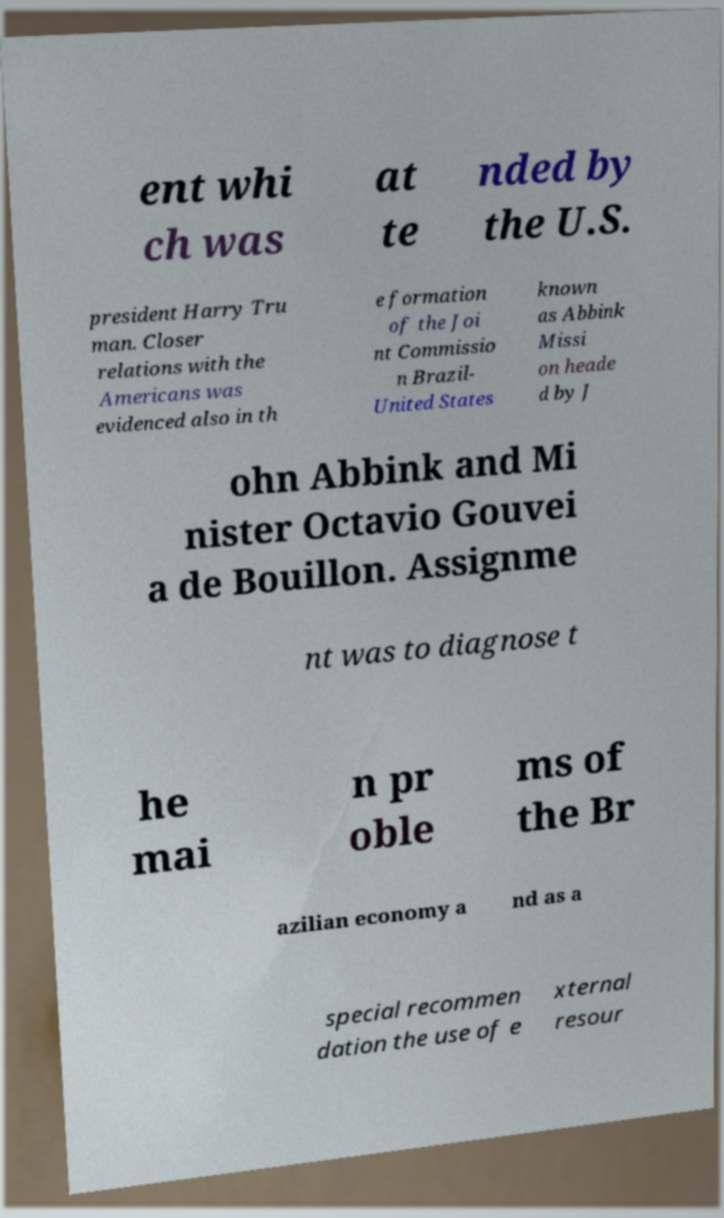There's text embedded in this image that I need extracted. Can you transcribe it verbatim? ent whi ch was at te nded by the U.S. president Harry Tru man. Closer relations with the Americans was evidenced also in th e formation of the Joi nt Commissio n Brazil- United States known as Abbink Missi on heade d by J ohn Abbink and Mi nister Octavio Gouvei a de Bouillon. Assignme nt was to diagnose t he mai n pr oble ms of the Br azilian economy a nd as a special recommen dation the use of e xternal resour 